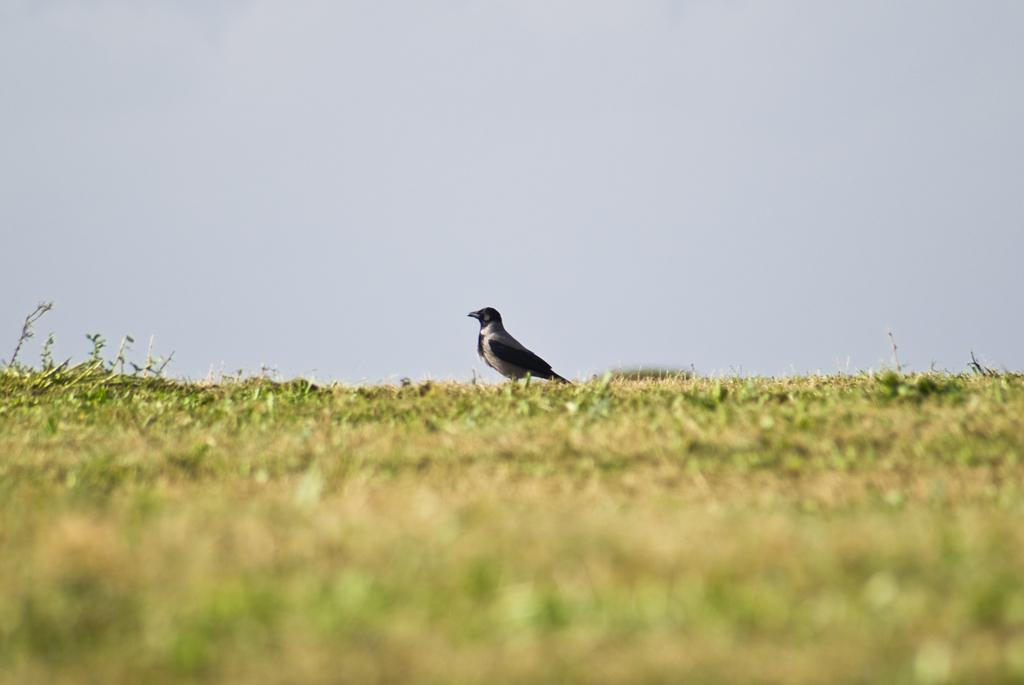What type of animal can be seen in the image? There is a bird in the image. What is on the ground in the image? There is grass on the ground in the image. What can be seen in the background of the image? The sky is visible in the background of the image. What type of vegetable is being grown in the image? There is no vegetable present in the image; it features a bird and grass. How many chickens can be seen in the image? There are no chickens present in the image; it features a bird. 